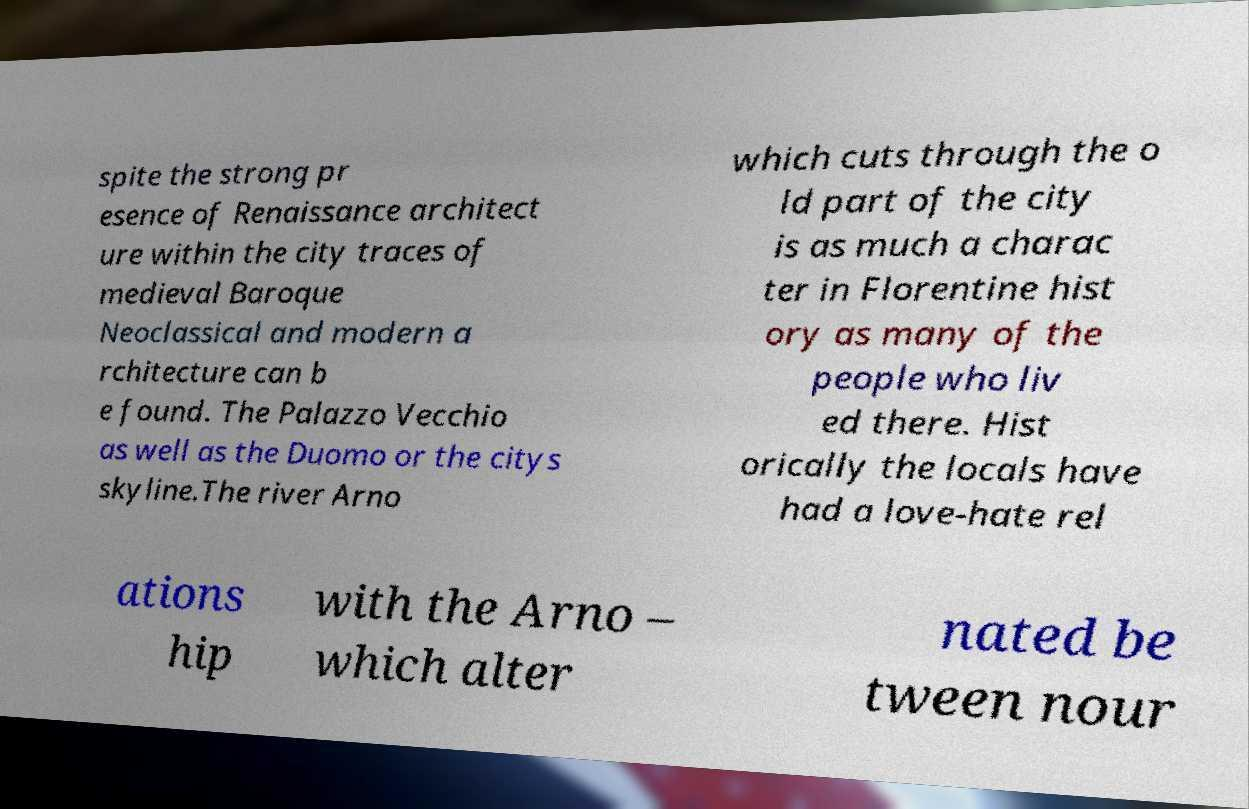Please read and relay the text visible in this image. What does it say? spite the strong pr esence of Renaissance architect ure within the city traces of medieval Baroque Neoclassical and modern a rchitecture can b e found. The Palazzo Vecchio as well as the Duomo or the citys skyline.The river Arno which cuts through the o ld part of the city is as much a charac ter in Florentine hist ory as many of the people who liv ed there. Hist orically the locals have had a love-hate rel ations hip with the Arno – which alter nated be tween nour 